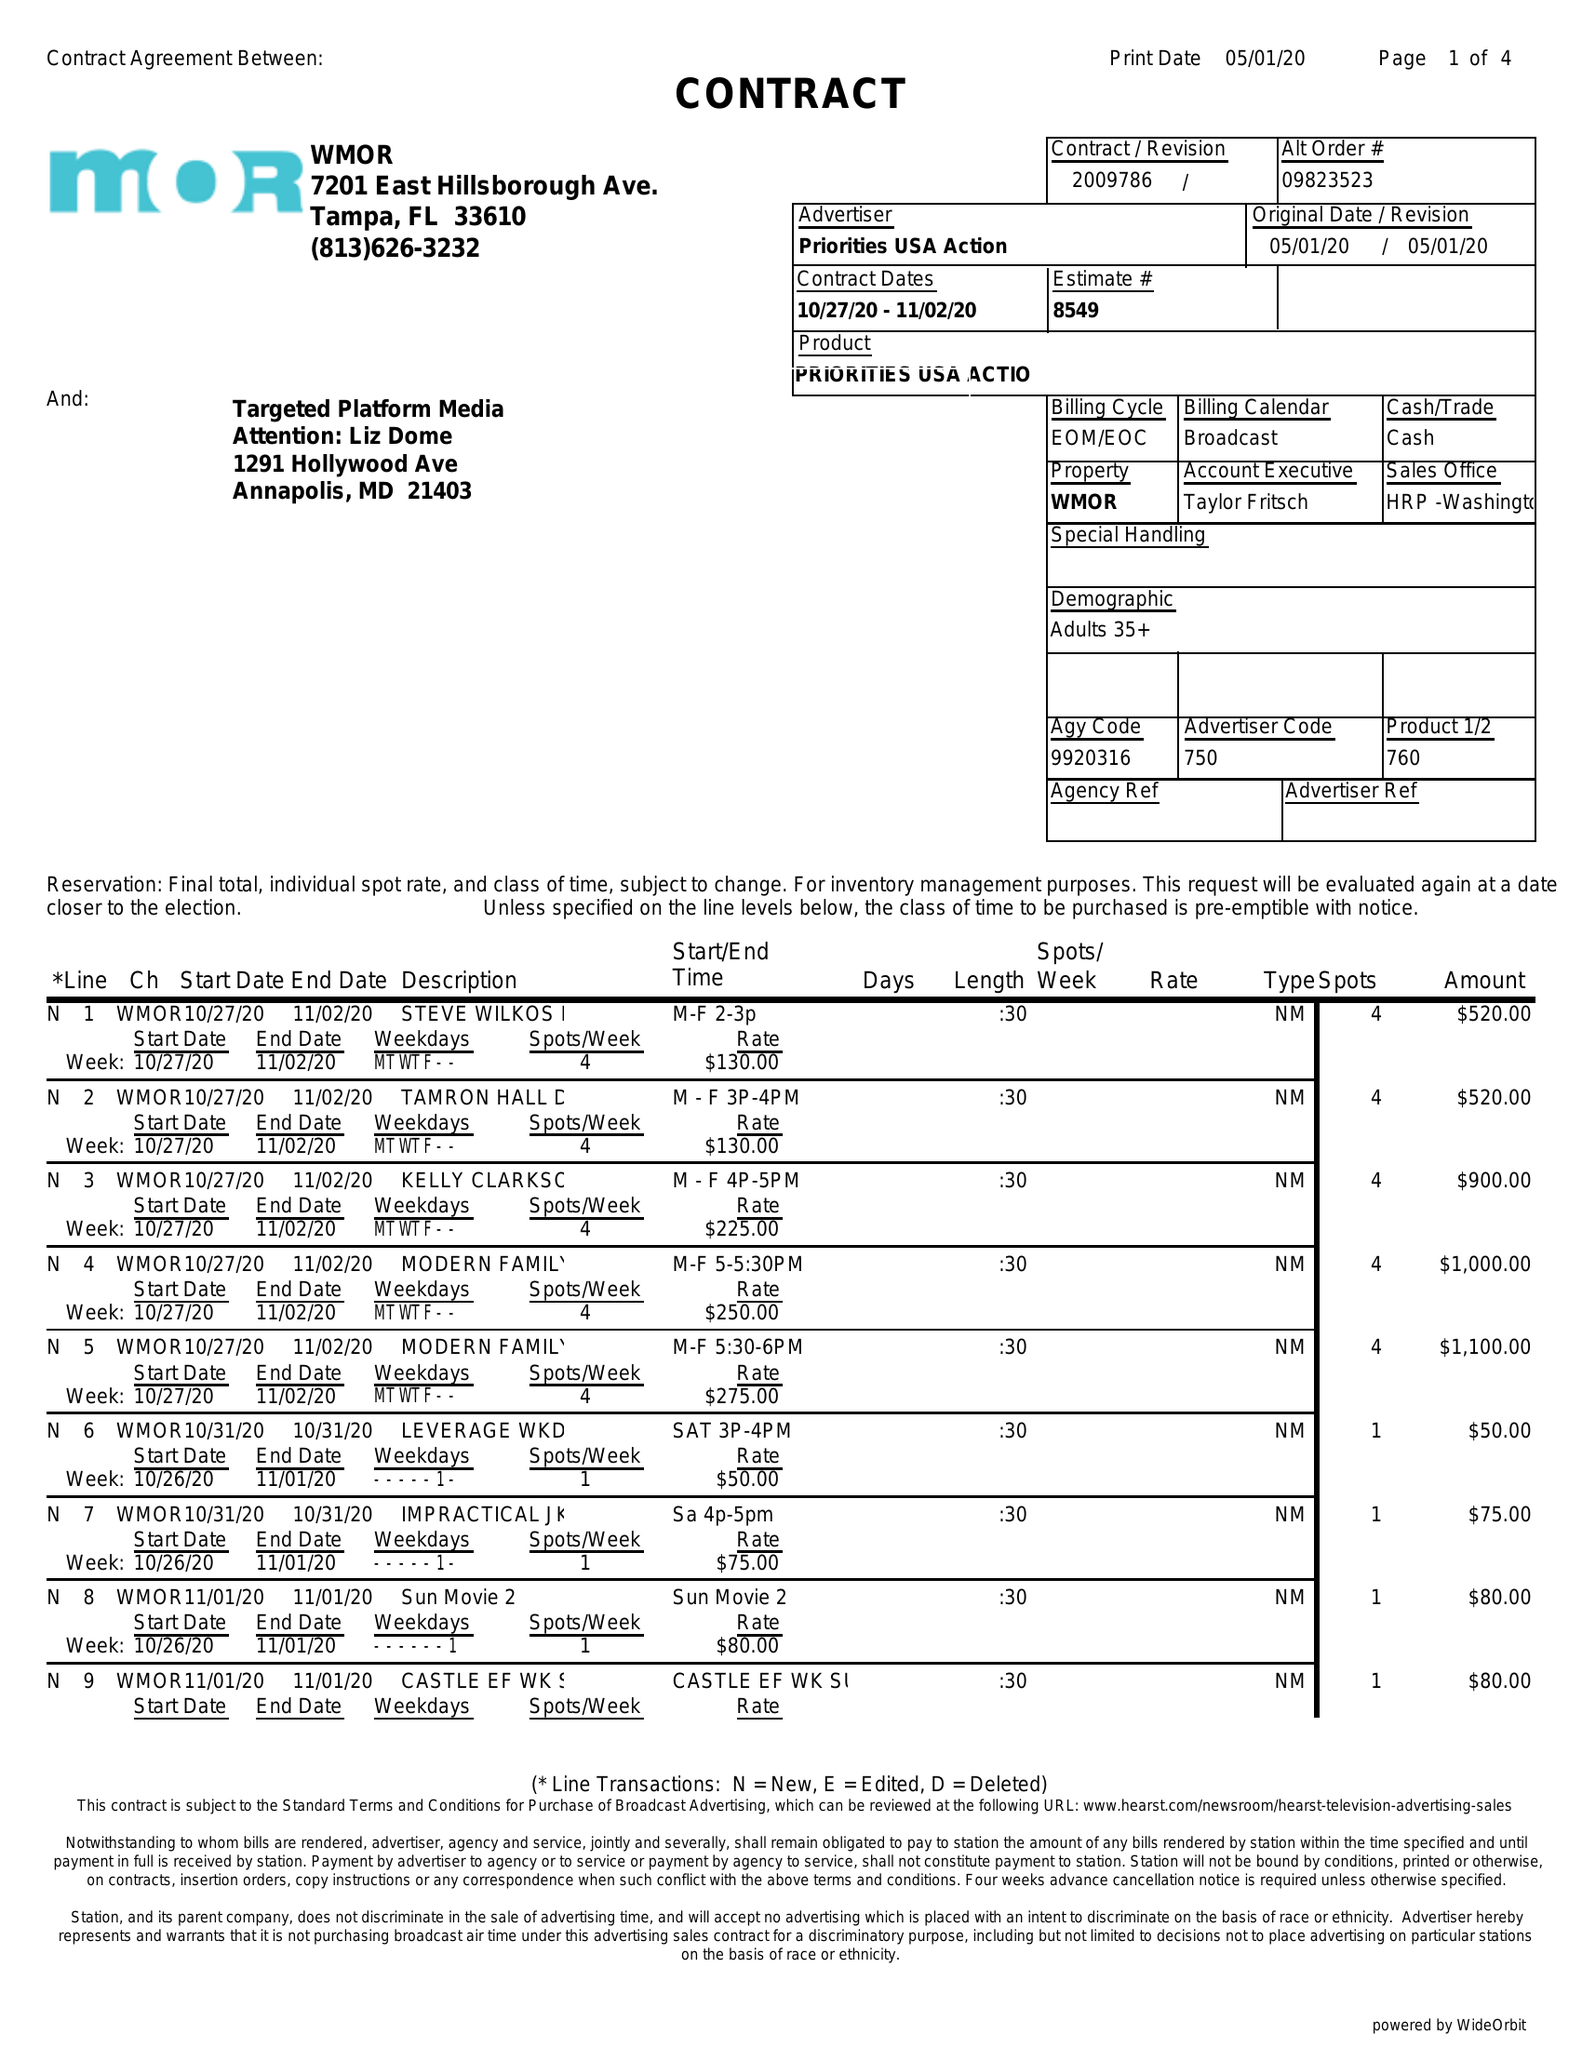What is the value for the advertiser?
Answer the question using a single word or phrase. PRIORITIES USA ACTION 